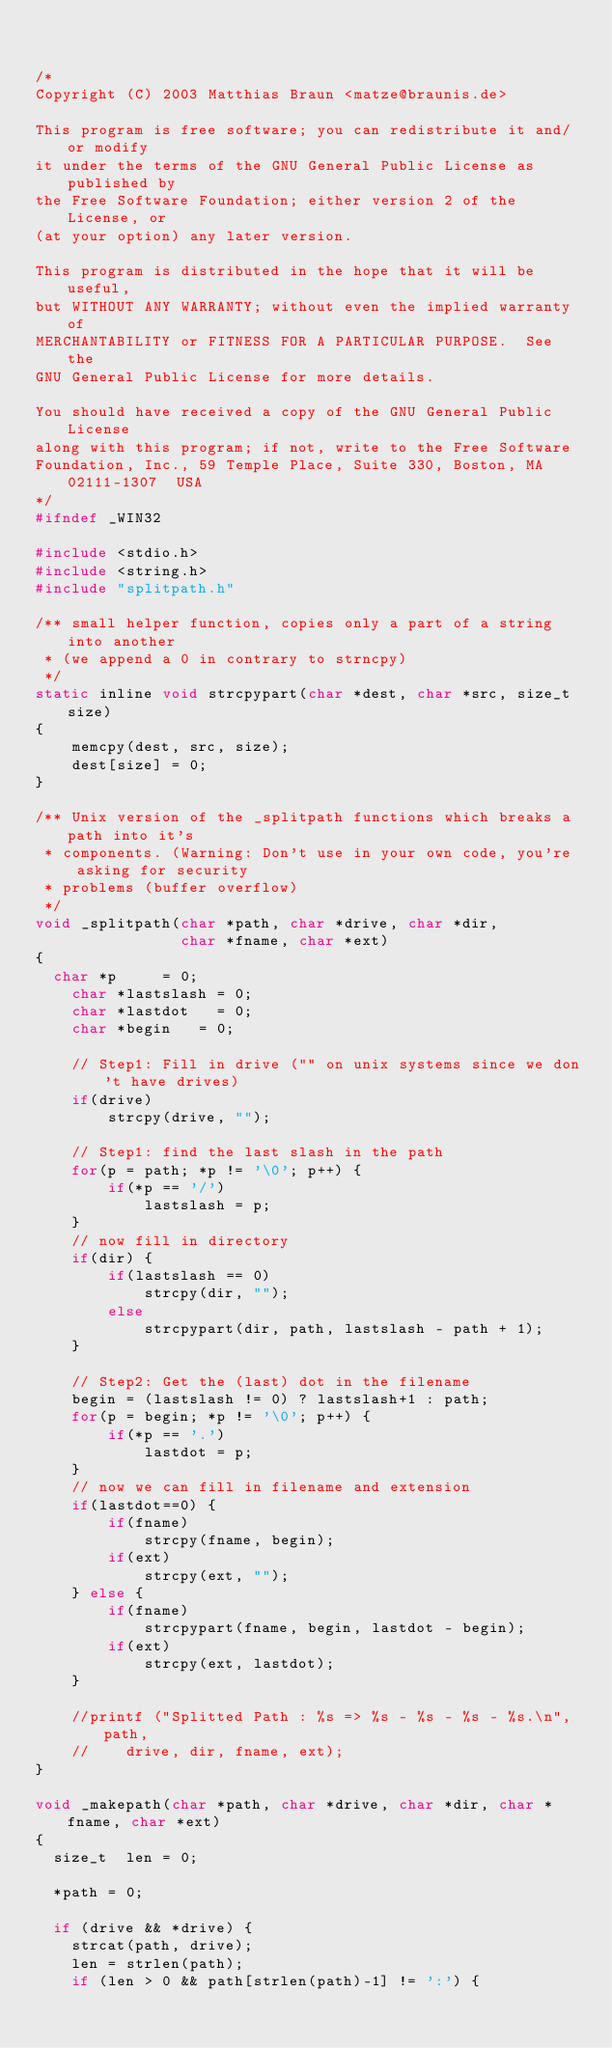<code> <loc_0><loc_0><loc_500><loc_500><_C_>

/*
Copyright (C) 2003 Matthias Braun <matze@braunis.de>
                                                                                
This program is free software; you can redistribute it and/or modify
it under the terms of the GNU General Public License as published by
the Free Software Foundation; either version 2 of the License, or
(at your option) any later version.
                                                                                
This program is distributed in the hope that it will be useful,
but WITHOUT ANY WARRANTY; without even the implied warranty of
MERCHANTABILITY or FITNESS FOR A PARTICULAR PURPOSE.  See the
GNU General Public License for more details.
                                                                                
You should have received a copy of the GNU General Public License
along with this program; if not, write to the Free Software
Foundation, Inc., 59 Temple Place, Suite 330, Boston, MA  02111-1307  USA
*/
#ifndef _WIN32

#include <stdio.h>
#include <string.h>
#include "splitpath.h"

/** small helper function, copies only a part of a string into another
 * (we append a 0 in contrary to strncpy)
 */
static inline void strcpypart(char *dest, char *src, size_t size)
{
    memcpy(dest, src, size);
    dest[size] = 0;
}

/** Unix version of the _splitpath functions which breaks a path into it's
 * components. (Warning: Don't use in your own code, you're asking for security
 * problems (buffer overflow)
 */
void _splitpath(char *path, char *drive, char *dir,
                char *fname, char *ext)
{
	char *p 		= 0;
    char *lastslash = 0;
    char *lastdot 	= 0;
    char *begin 	= 0;
	
    // Step1: Fill in drive ("" on unix systems since we don't have drives)
    if(drive)
        strcpy(drive, "");

    // Step1: find the last slash in the path
    for(p = path; *p != '\0'; p++) {
        if(*p == '/')
            lastslash = p;
    }
    // now fill in directory
    if(dir) {
        if(lastslash == 0)
            strcpy(dir, "");
        else
            strcpypart(dir, path, lastslash - path + 1);
    }

    // Step2: Get the (last) dot in the filename
    begin = (lastslash != 0) ? lastslash+1 : path;
    for(p = begin; *p != '\0'; p++) {
        if(*p == '.')
            lastdot = p;
    }
    // now we can fill in filename and extension
    if(lastdot==0) {
        if(fname)
            strcpy(fname, begin);
        if(ext)
            strcpy(ext, "");
    } else {
        if(fname)
            strcpypart(fname, begin, lastdot - begin);
        if(ext)
            strcpy(ext, lastdot);
    }

    //printf ("Splitted Path : %s => %s - %s - %s - %s.\n", path,
    //		drive, dir, fname, ext);
}

void _makepath(char *path, char *drive, char *dir, char *fname, char *ext)
{
	size_t	len = 0;
	
	*path = 0;
	
	if (drive && *drive) {
		strcat(path, drive);
		len = strlen(path);
		if (len > 0 && path[strlen(path)-1] != ':') {</code> 